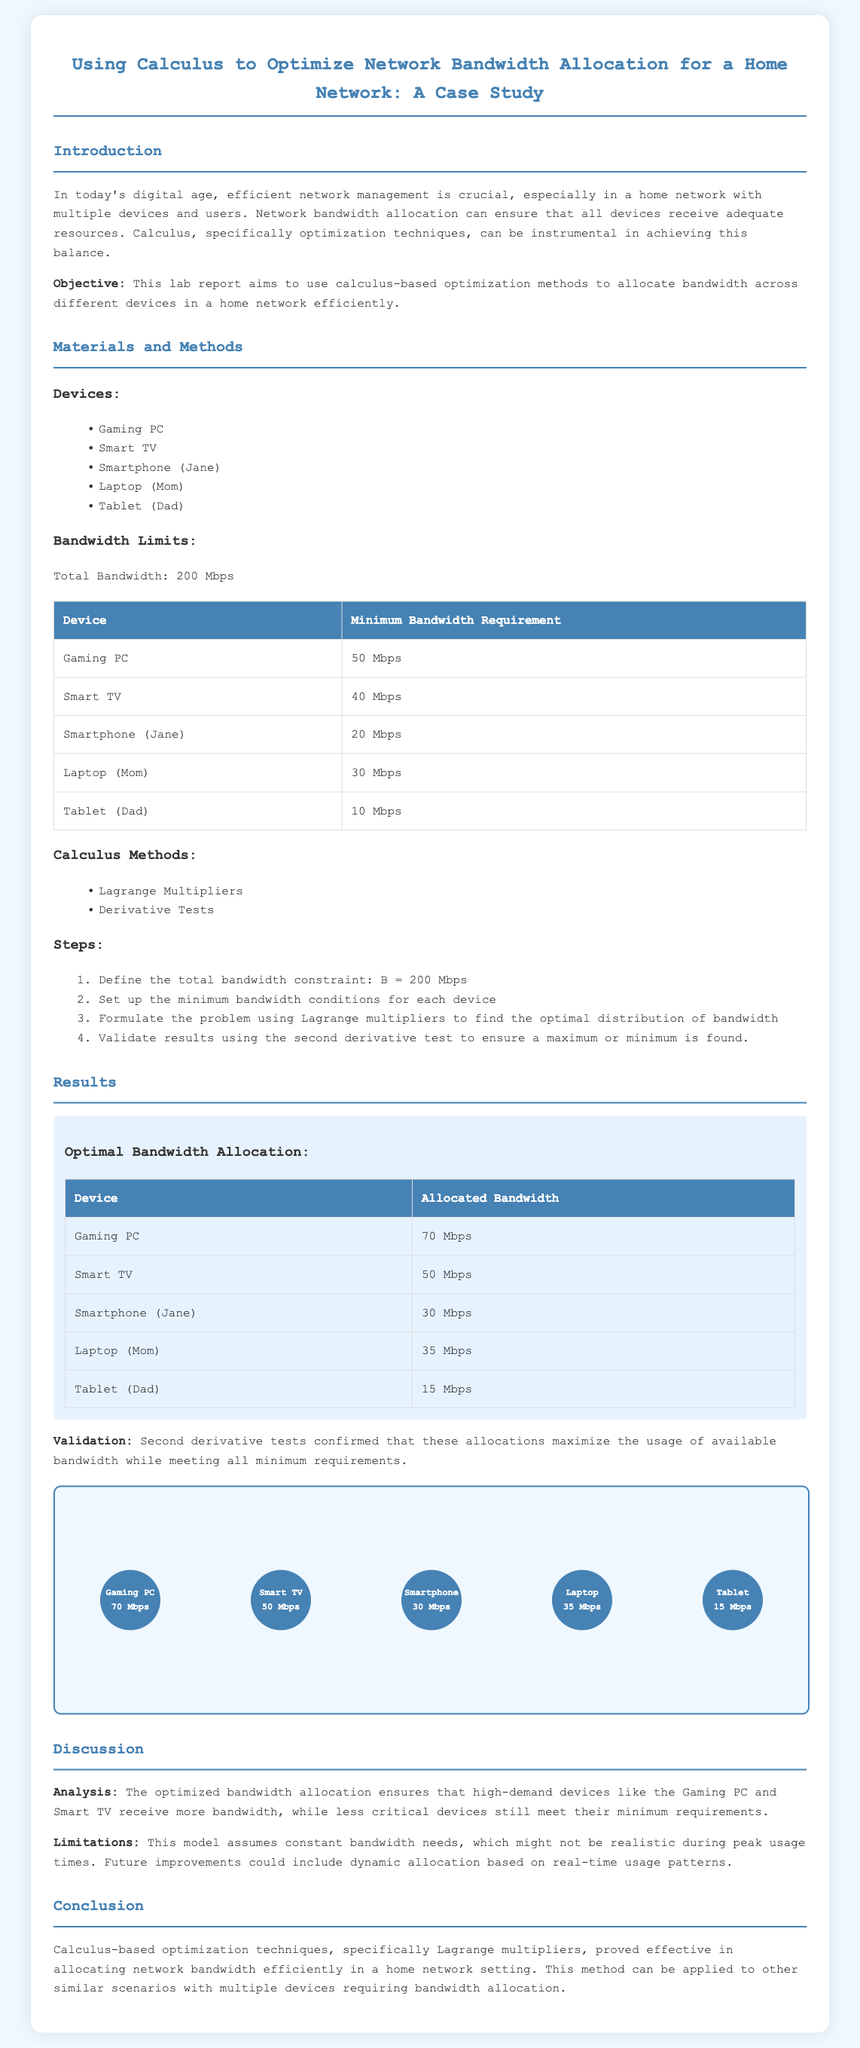What is the total bandwidth? The total bandwidth is stated in the document as 200 Mbps.
Answer: 200 Mbps What is the minimum bandwidth requirement for the Gaming PC? The minimum requirement for the Gaming PC is specified in the table as 50 Mbps.
Answer: 50 Mbps Which optimization method was used in the study? The document mentions using Lagrange Multipliers as a calculus method.
Answer: Lagrange Multipliers What was the allocated bandwidth for the Smart TV? The optimal bandwidth allocation table lists the Smart TV's allocation as 50 Mbps.
Answer: 50 Mbps What is the limitation noted in the discussion? The report mentions that the model assumes constant bandwidth needs during peak usage times as a limitation.
Answer: Constant bandwidth needs How many devices were analyzed in the case study? There are five devices listed in the devices section of the document.
Answer: Five What method was used to validate the results? The validation method employed was the second derivative test as stated in the results section.
Answer: Second derivative test What bandwidth was allocated to the Tablet? According to the results, the Tablet was allocated 15 Mbps.
Answer: 15 Mbps What is the main objective of the lab report? The objective is to use calculus-based optimization methods for bandwidth allocation efficiently.
Answer: Efficient bandwidth allocation 